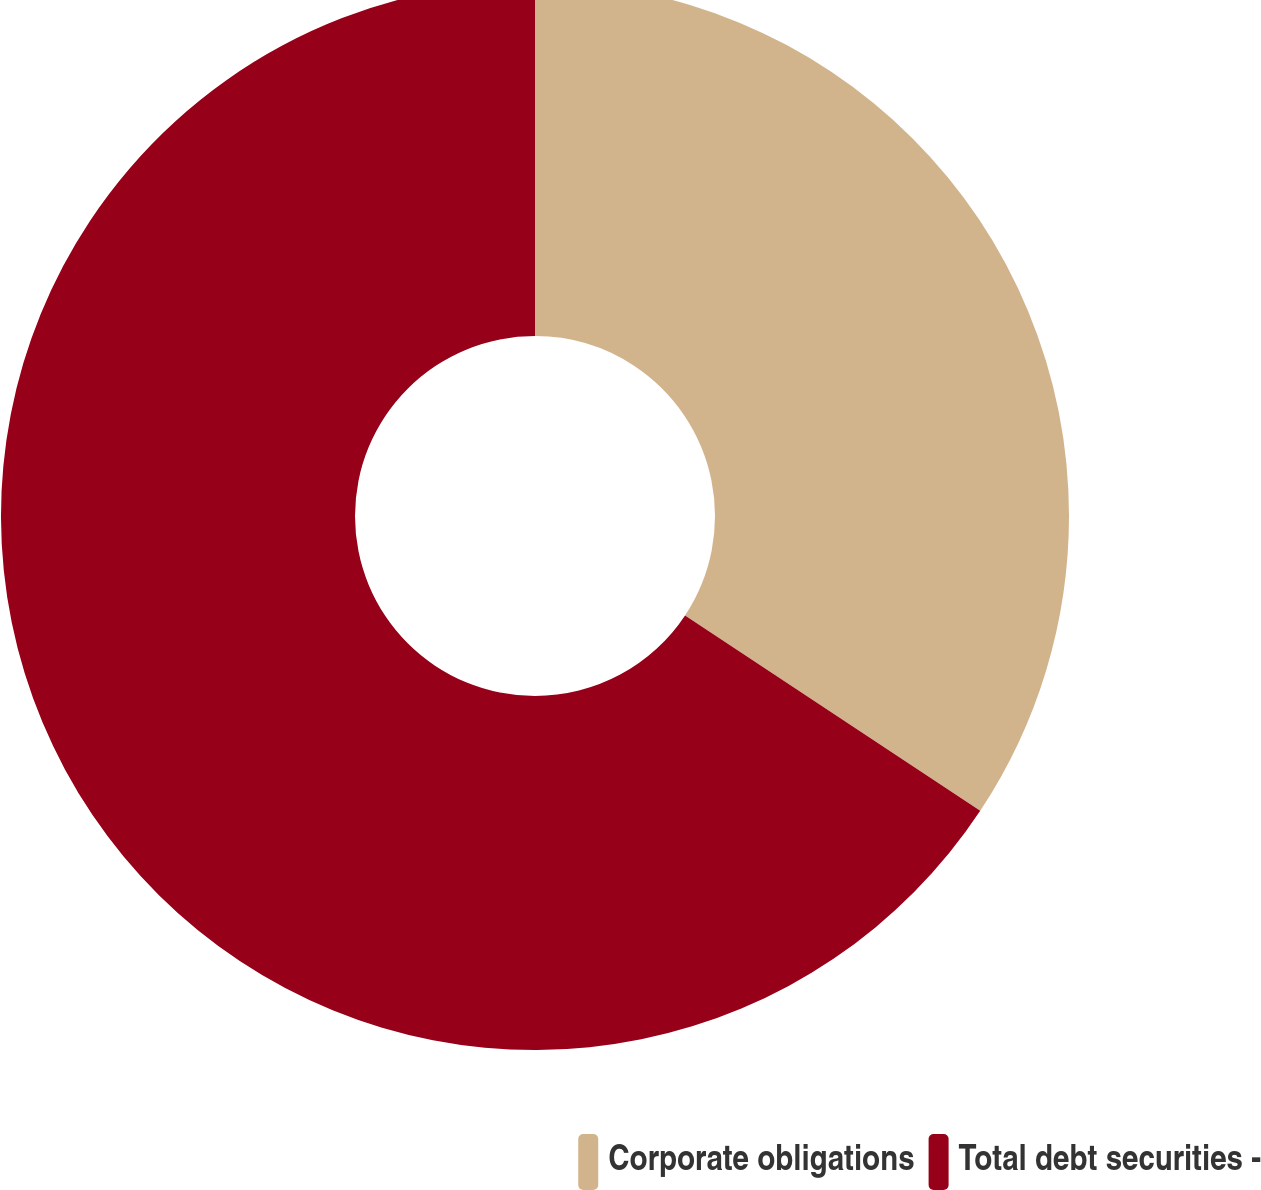<chart> <loc_0><loc_0><loc_500><loc_500><pie_chart><fcel>Corporate obligations<fcel>Total debt securities -<nl><fcel>34.31%<fcel>65.69%<nl></chart> 